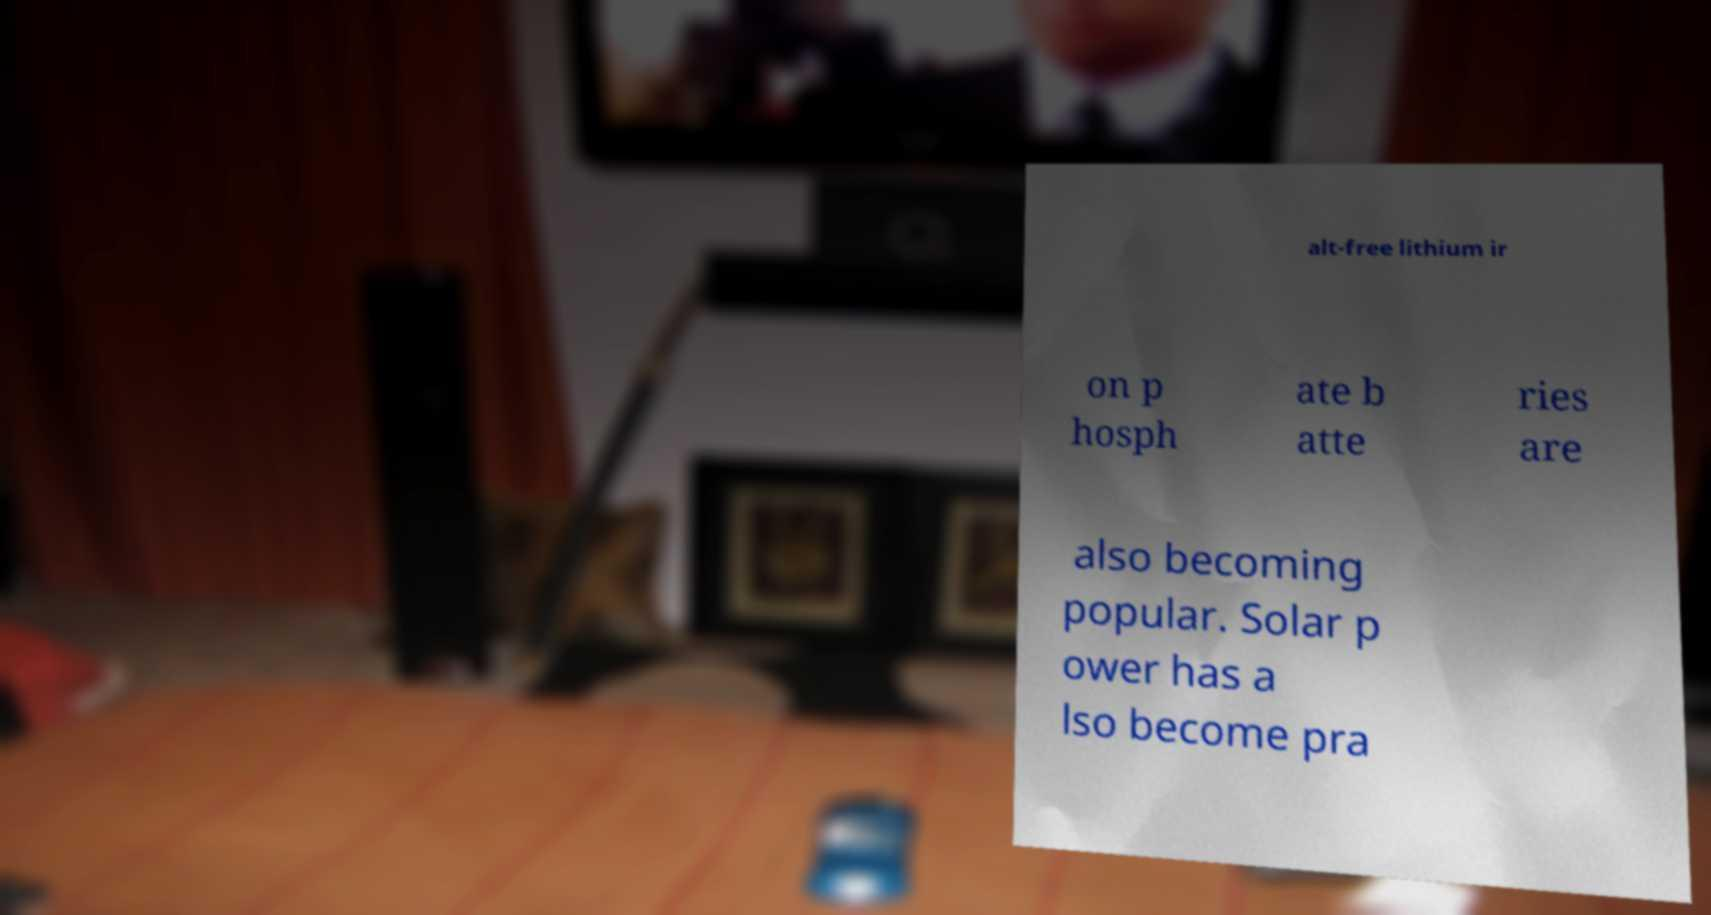Could you assist in decoding the text presented in this image and type it out clearly? alt-free lithium ir on p hosph ate b atte ries are also becoming popular. Solar p ower has a lso become pra 